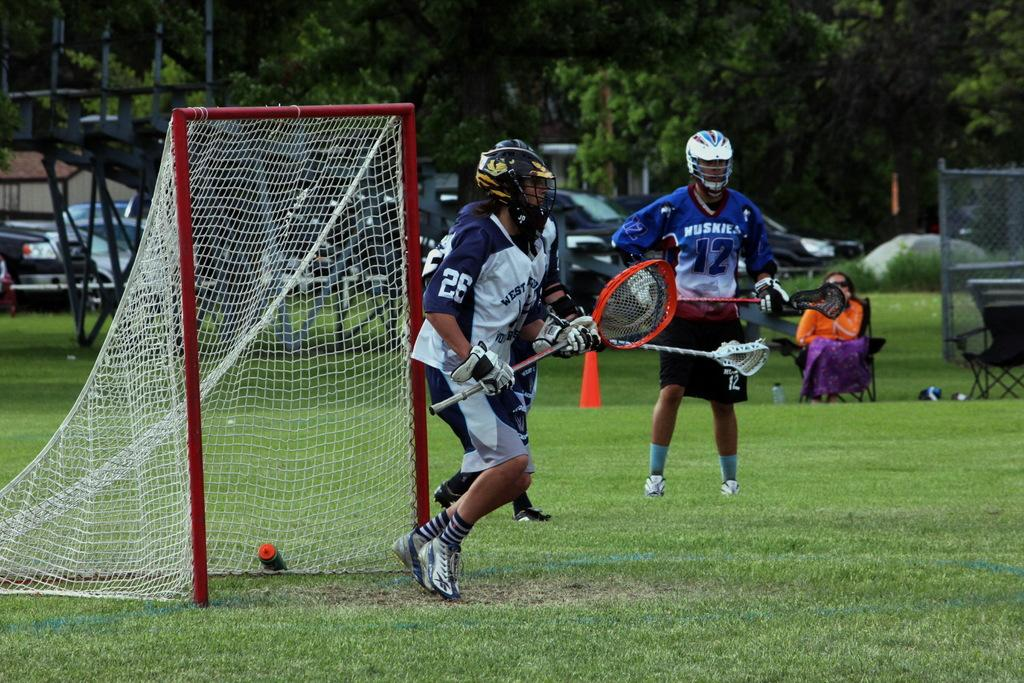<image>
Summarize the visual content of the image. players from west end and huskies playing game 